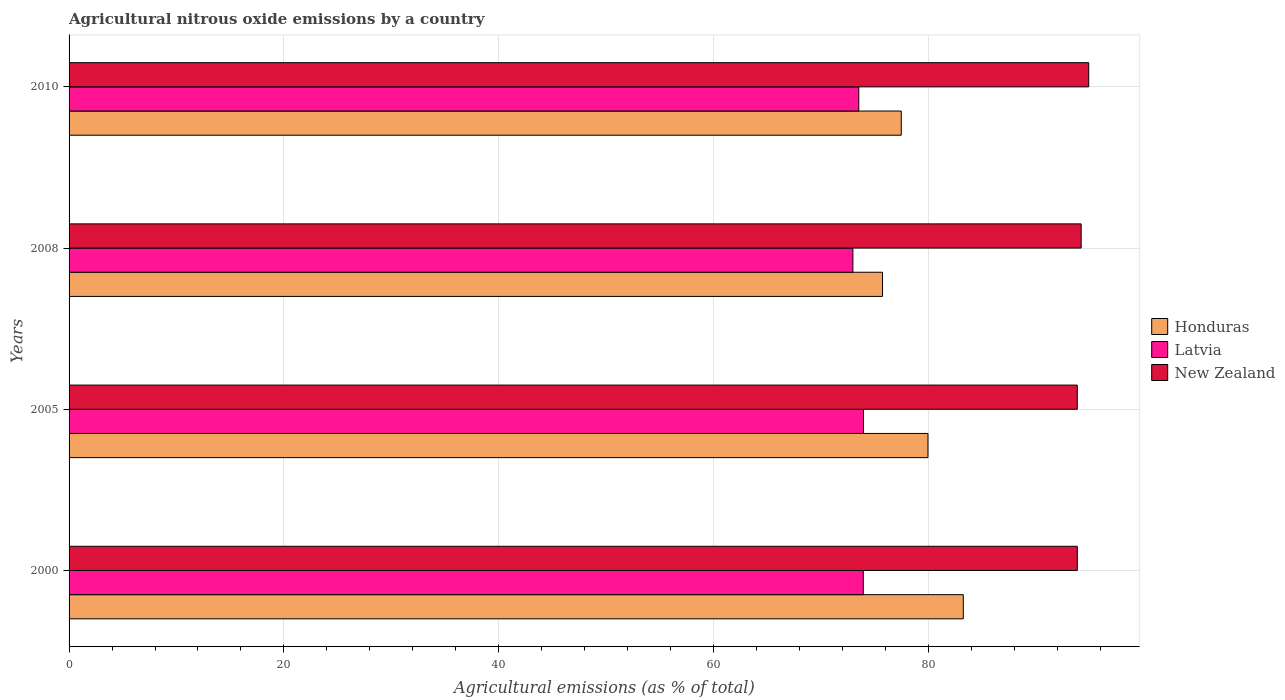How many bars are there on the 3rd tick from the bottom?
Ensure brevity in your answer.  3. What is the label of the 1st group of bars from the top?
Your answer should be compact. 2010. In how many cases, is the number of bars for a given year not equal to the number of legend labels?
Keep it short and to the point. 0. What is the amount of agricultural nitrous oxide emitted in Honduras in 2010?
Ensure brevity in your answer.  77.46. Across all years, what is the maximum amount of agricultural nitrous oxide emitted in New Zealand?
Provide a succinct answer. 94.91. Across all years, what is the minimum amount of agricultural nitrous oxide emitted in New Zealand?
Make the answer very short. 93.85. What is the total amount of agricultural nitrous oxide emitted in Latvia in the graph?
Offer a very short reply. 294.34. What is the difference between the amount of agricultural nitrous oxide emitted in Honduras in 2005 and that in 2008?
Your response must be concise. 4.23. What is the difference between the amount of agricultural nitrous oxide emitted in Honduras in 2005 and the amount of agricultural nitrous oxide emitted in New Zealand in 2008?
Offer a terse response. -14.26. What is the average amount of agricultural nitrous oxide emitted in Honduras per year?
Offer a very short reply. 79.09. In the year 2010, what is the difference between the amount of agricultural nitrous oxide emitted in Honduras and amount of agricultural nitrous oxide emitted in New Zealand?
Ensure brevity in your answer.  -17.45. What is the ratio of the amount of agricultural nitrous oxide emitted in New Zealand in 2005 to that in 2010?
Make the answer very short. 0.99. Is the difference between the amount of agricultural nitrous oxide emitted in Honduras in 2005 and 2010 greater than the difference between the amount of agricultural nitrous oxide emitted in New Zealand in 2005 and 2010?
Offer a very short reply. Yes. What is the difference between the highest and the second highest amount of agricultural nitrous oxide emitted in New Zealand?
Provide a short and direct response. 0.7. What is the difference between the highest and the lowest amount of agricultural nitrous oxide emitted in New Zealand?
Provide a short and direct response. 1.06. In how many years, is the amount of agricultural nitrous oxide emitted in Latvia greater than the average amount of agricultural nitrous oxide emitted in Latvia taken over all years?
Give a very brief answer. 2. Is the sum of the amount of agricultural nitrous oxide emitted in New Zealand in 2005 and 2008 greater than the maximum amount of agricultural nitrous oxide emitted in Latvia across all years?
Offer a terse response. Yes. What does the 3rd bar from the top in 2010 represents?
Offer a terse response. Honduras. What does the 2nd bar from the bottom in 2000 represents?
Your answer should be very brief. Latvia. Is it the case that in every year, the sum of the amount of agricultural nitrous oxide emitted in Honduras and amount of agricultural nitrous oxide emitted in New Zealand is greater than the amount of agricultural nitrous oxide emitted in Latvia?
Your answer should be very brief. Yes. How many bars are there?
Make the answer very short. 12. What is the difference between two consecutive major ticks on the X-axis?
Make the answer very short. 20. Does the graph contain any zero values?
Your answer should be very brief. No. What is the title of the graph?
Your answer should be very brief. Agricultural nitrous oxide emissions by a country. What is the label or title of the X-axis?
Your answer should be very brief. Agricultural emissions (as % of total). What is the Agricultural emissions (as % of total) in Honduras in 2000?
Provide a short and direct response. 83.23. What is the Agricultural emissions (as % of total) of Latvia in 2000?
Your response must be concise. 73.93. What is the Agricultural emissions (as % of total) of New Zealand in 2000?
Provide a succinct answer. 93.85. What is the Agricultural emissions (as % of total) in Honduras in 2005?
Provide a short and direct response. 79.95. What is the Agricultural emissions (as % of total) of Latvia in 2005?
Give a very brief answer. 73.94. What is the Agricultural emissions (as % of total) of New Zealand in 2005?
Make the answer very short. 93.85. What is the Agricultural emissions (as % of total) in Honduras in 2008?
Keep it short and to the point. 75.72. What is the Agricultural emissions (as % of total) in Latvia in 2008?
Provide a succinct answer. 72.96. What is the Agricultural emissions (as % of total) of New Zealand in 2008?
Ensure brevity in your answer.  94.21. What is the Agricultural emissions (as % of total) of Honduras in 2010?
Provide a succinct answer. 77.46. What is the Agricultural emissions (as % of total) in Latvia in 2010?
Offer a terse response. 73.51. What is the Agricultural emissions (as % of total) in New Zealand in 2010?
Make the answer very short. 94.91. Across all years, what is the maximum Agricultural emissions (as % of total) of Honduras?
Provide a succinct answer. 83.23. Across all years, what is the maximum Agricultural emissions (as % of total) in Latvia?
Make the answer very short. 73.94. Across all years, what is the maximum Agricultural emissions (as % of total) of New Zealand?
Provide a succinct answer. 94.91. Across all years, what is the minimum Agricultural emissions (as % of total) in Honduras?
Provide a short and direct response. 75.72. Across all years, what is the minimum Agricultural emissions (as % of total) in Latvia?
Offer a very short reply. 72.96. Across all years, what is the minimum Agricultural emissions (as % of total) in New Zealand?
Offer a very short reply. 93.85. What is the total Agricultural emissions (as % of total) in Honduras in the graph?
Your response must be concise. 316.36. What is the total Agricultural emissions (as % of total) in Latvia in the graph?
Offer a very short reply. 294.34. What is the total Agricultural emissions (as % of total) in New Zealand in the graph?
Ensure brevity in your answer.  376.81. What is the difference between the Agricultural emissions (as % of total) of Honduras in 2000 and that in 2005?
Your answer should be compact. 3.29. What is the difference between the Agricultural emissions (as % of total) of Latvia in 2000 and that in 2005?
Provide a short and direct response. -0.02. What is the difference between the Agricultural emissions (as % of total) of New Zealand in 2000 and that in 2005?
Offer a very short reply. 0. What is the difference between the Agricultural emissions (as % of total) in Honduras in 2000 and that in 2008?
Provide a succinct answer. 7.52. What is the difference between the Agricultural emissions (as % of total) in Latvia in 2000 and that in 2008?
Provide a succinct answer. 0.97. What is the difference between the Agricultural emissions (as % of total) in New Zealand in 2000 and that in 2008?
Give a very brief answer. -0.36. What is the difference between the Agricultural emissions (as % of total) in Honduras in 2000 and that in 2010?
Your answer should be compact. 5.77. What is the difference between the Agricultural emissions (as % of total) in Latvia in 2000 and that in 2010?
Provide a short and direct response. 0.42. What is the difference between the Agricultural emissions (as % of total) in New Zealand in 2000 and that in 2010?
Offer a very short reply. -1.06. What is the difference between the Agricultural emissions (as % of total) in Honduras in 2005 and that in 2008?
Your answer should be very brief. 4.23. What is the difference between the Agricultural emissions (as % of total) in Latvia in 2005 and that in 2008?
Ensure brevity in your answer.  0.99. What is the difference between the Agricultural emissions (as % of total) in New Zealand in 2005 and that in 2008?
Your response must be concise. -0.36. What is the difference between the Agricultural emissions (as % of total) of Honduras in 2005 and that in 2010?
Your response must be concise. 2.49. What is the difference between the Agricultural emissions (as % of total) of Latvia in 2005 and that in 2010?
Your response must be concise. 0.44. What is the difference between the Agricultural emissions (as % of total) of New Zealand in 2005 and that in 2010?
Give a very brief answer. -1.06. What is the difference between the Agricultural emissions (as % of total) of Honduras in 2008 and that in 2010?
Make the answer very short. -1.74. What is the difference between the Agricultural emissions (as % of total) in Latvia in 2008 and that in 2010?
Give a very brief answer. -0.55. What is the difference between the Agricultural emissions (as % of total) in New Zealand in 2008 and that in 2010?
Provide a succinct answer. -0.7. What is the difference between the Agricultural emissions (as % of total) of Honduras in 2000 and the Agricultural emissions (as % of total) of Latvia in 2005?
Provide a succinct answer. 9.29. What is the difference between the Agricultural emissions (as % of total) of Honduras in 2000 and the Agricultural emissions (as % of total) of New Zealand in 2005?
Provide a short and direct response. -10.61. What is the difference between the Agricultural emissions (as % of total) of Latvia in 2000 and the Agricultural emissions (as % of total) of New Zealand in 2005?
Give a very brief answer. -19.92. What is the difference between the Agricultural emissions (as % of total) of Honduras in 2000 and the Agricultural emissions (as % of total) of Latvia in 2008?
Keep it short and to the point. 10.28. What is the difference between the Agricultural emissions (as % of total) in Honduras in 2000 and the Agricultural emissions (as % of total) in New Zealand in 2008?
Offer a very short reply. -10.97. What is the difference between the Agricultural emissions (as % of total) in Latvia in 2000 and the Agricultural emissions (as % of total) in New Zealand in 2008?
Your response must be concise. -20.28. What is the difference between the Agricultural emissions (as % of total) of Honduras in 2000 and the Agricultural emissions (as % of total) of Latvia in 2010?
Keep it short and to the point. 9.73. What is the difference between the Agricultural emissions (as % of total) of Honduras in 2000 and the Agricultural emissions (as % of total) of New Zealand in 2010?
Offer a very short reply. -11.67. What is the difference between the Agricultural emissions (as % of total) in Latvia in 2000 and the Agricultural emissions (as % of total) in New Zealand in 2010?
Offer a very short reply. -20.98. What is the difference between the Agricultural emissions (as % of total) in Honduras in 2005 and the Agricultural emissions (as % of total) in Latvia in 2008?
Your answer should be very brief. 6.99. What is the difference between the Agricultural emissions (as % of total) in Honduras in 2005 and the Agricultural emissions (as % of total) in New Zealand in 2008?
Provide a short and direct response. -14.26. What is the difference between the Agricultural emissions (as % of total) of Latvia in 2005 and the Agricultural emissions (as % of total) of New Zealand in 2008?
Keep it short and to the point. -20.26. What is the difference between the Agricultural emissions (as % of total) in Honduras in 2005 and the Agricultural emissions (as % of total) in Latvia in 2010?
Offer a very short reply. 6.44. What is the difference between the Agricultural emissions (as % of total) in Honduras in 2005 and the Agricultural emissions (as % of total) in New Zealand in 2010?
Your response must be concise. -14.96. What is the difference between the Agricultural emissions (as % of total) in Latvia in 2005 and the Agricultural emissions (as % of total) in New Zealand in 2010?
Offer a very short reply. -20.96. What is the difference between the Agricultural emissions (as % of total) in Honduras in 2008 and the Agricultural emissions (as % of total) in Latvia in 2010?
Provide a short and direct response. 2.21. What is the difference between the Agricultural emissions (as % of total) in Honduras in 2008 and the Agricultural emissions (as % of total) in New Zealand in 2010?
Your response must be concise. -19.19. What is the difference between the Agricultural emissions (as % of total) in Latvia in 2008 and the Agricultural emissions (as % of total) in New Zealand in 2010?
Provide a short and direct response. -21.95. What is the average Agricultural emissions (as % of total) in Honduras per year?
Make the answer very short. 79.09. What is the average Agricultural emissions (as % of total) of Latvia per year?
Your answer should be compact. 73.58. What is the average Agricultural emissions (as % of total) in New Zealand per year?
Give a very brief answer. 94.2. In the year 2000, what is the difference between the Agricultural emissions (as % of total) of Honduras and Agricultural emissions (as % of total) of Latvia?
Provide a short and direct response. 9.31. In the year 2000, what is the difference between the Agricultural emissions (as % of total) of Honduras and Agricultural emissions (as % of total) of New Zealand?
Keep it short and to the point. -10.61. In the year 2000, what is the difference between the Agricultural emissions (as % of total) in Latvia and Agricultural emissions (as % of total) in New Zealand?
Keep it short and to the point. -19.92. In the year 2005, what is the difference between the Agricultural emissions (as % of total) of Honduras and Agricultural emissions (as % of total) of Latvia?
Keep it short and to the point. 6. In the year 2005, what is the difference between the Agricultural emissions (as % of total) of Honduras and Agricultural emissions (as % of total) of New Zealand?
Your response must be concise. -13.9. In the year 2005, what is the difference between the Agricultural emissions (as % of total) in Latvia and Agricultural emissions (as % of total) in New Zealand?
Provide a succinct answer. -19.9. In the year 2008, what is the difference between the Agricultural emissions (as % of total) of Honduras and Agricultural emissions (as % of total) of Latvia?
Offer a terse response. 2.76. In the year 2008, what is the difference between the Agricultural emissions (as % of total) in Honduras and Agricultural emissions (as % of total) in New Zealand?
Provide a short and direct response. -18.49. In the year 2008, what is the difference between the Agricultural emissions (as % of total) in Latvia and Agricultural emissions (as % of total) in New Zealand?
Offer a very short reply. -21.25. In the year 2010, what is the difference between the Agricultural emissions (as % of total) of Honduras and Agricultural emissions (as % of total) of Latvia?
Keep it short and to the point. 3.95. In the year 2010, what is the difference between the Agricultural emissions (as % of total) in Honduras and Agricultural emissions (as % of total) in New Zealand?
Provide a succinct answer. -17.45. In the year 2010, what is the difference between the Agricultural emissions (as % of total) of Latvia and Agricultural emissions (as % of total) of New Zealand?
Offer a very short reply. -21.4. What is the ratio of the Agricultural emissions (as % of total) in Honduras in 2000 to that in 2005?
Offer a terse response. 1.04. What is the ratio of the Agricultural emissions (as % of total) in Latvia in 2000 to that in 2005?
Offer a very short reply. 1. What is the ratio of the Agricultural emissions (as % of total) of Honduras in 2000 to that in 2008?
Offer a very short reply. 1.1. What is the ratio of the Agricultural emissions (as % of total) of Latvia in 2000 to that in 2008?
Provide a succinct answer. 1.01. What is the ratio of the Agricultural emissions (as % of total) of Honduras in 2000 to that in 2010?
Make the answer very short. 1.07. What is the ratio of the Agricultural emissions (as % of total) of New Zealand in 2000 to that in 2010?
Your answer should be very brief. 0.99. What is the ratio of the Agricultural emissions (as % of total) in Honduras in 2005 to that in 2008?
Give a very brief answer. 1.06. What is the ratio of the Agricultural emissions (as % of total) in Latvia in 2005 to that in 2008?
Ensure brevity in your answer.  1.01. What is the ratio of the Agricultural emissions (as % of total) in New Zealand in 2005 to that in 2008?
Your answer should be compact. 1. What is the ratio of the Agricultural emissions (as % of total) in Honduras in 2005 to that in 2010?
Make the answer very short. 1.03. What is the ratio of the Agricultural emissions (as % of total) in Latvia in 2005 to that in 2010?
Give a very brief answer. 1.01. What is the ratio of the Agricultural emissions (as % of total) in New Zealand in 2005 to that in 2010?
Give a very brief answer. 0.99. What is the ratio of the Agricultural emissions (as % of total) in Honduras in 2008 to that in 2010?
Give a very brief answer. 0.98. What is the ratio of the Agricultural emissions (as % of total) in Latvia in 2008 to that in 2010?
Ensure brevity in your answer.  0.99. What is the difference between the highest and the second highest Agricultural emissions (as % of total) in Honduras?
Your answer should be very brief. 3.29. What is the difference between the highest and the second highest Agricultural emissions (as % of total) in Latvia?
Ensure brevity in your answer.  0.02. What is the difference between the highest and the second highest Agricultural emissions (as % of total) of New Zealand?
Provide a short and direct response. 0.7. What is the difference between the highest and the lowest Agricultural emissions (as % of total) of Honduras?
Provide a short and direct response. 7.52. What is the difference between the highest and the lowest Agricultural emissions (as % of total) of Latvia?
Make the answer very short. 0.99. What is the difference between the highest and the lowest Agricultural emissions (as % of total) of New Zealand?
Provide a short and direct response. 1.06. 